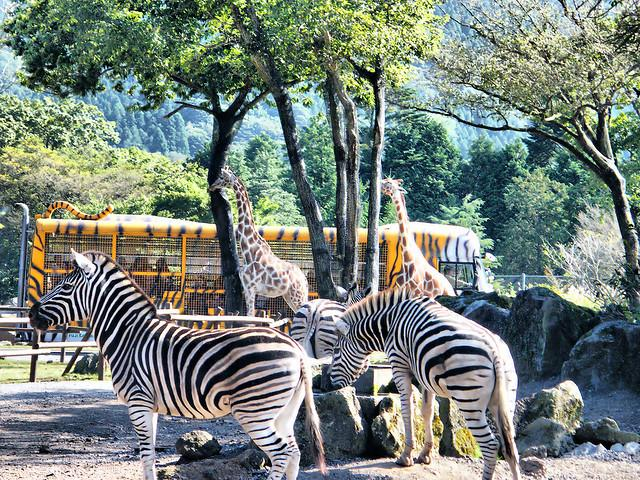What kind of vehicle is the yellow thing?

Choices:
A) tour bus
B) truck
C) school bus
D) train tour bus 